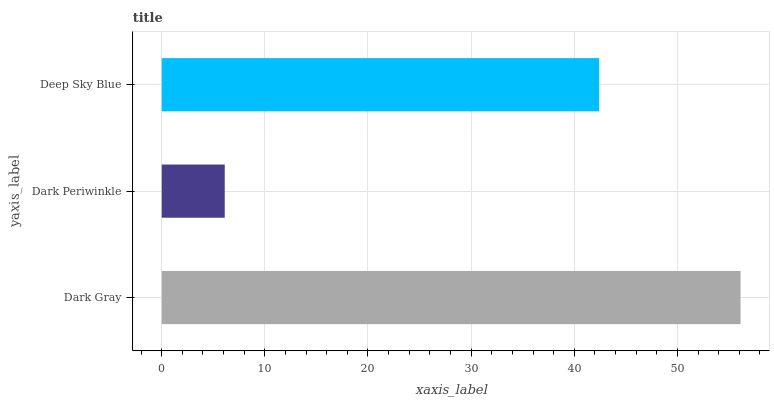Is Dark Periwinkle the minimum?
Answer yes or no. Yes. Is Dark Gray the maximum?
Answer yes or no. Yes. Is Deep Sky Blue the minimum?
Answer yes or no. No. Is Deep Sky Blue the maximum?
Answer yes or no. No. Is Deep Sky Blue greater than Dark Periwinkle?
Answer yes or no. Yes. Is Dark Periwinkle less than Deep Sky Blue?
Answer yes or no. Yes. Is Dark Periwinkle greater than Deep Sky Blue?
Answer yes or no. No. Is Deep Sky Blue less than Dark Periwinkle?
Answer yes or no. No. Is Deep Sky Blue the high median?
Answer yes or no. Yes. Is Deep Sky Blue the low median?
Answer yes or no. Yes. Is Dark Periwinkle the high median?
Answer yes or no. No. Is Dark Gray the low median?
Answer yes or no. No. 